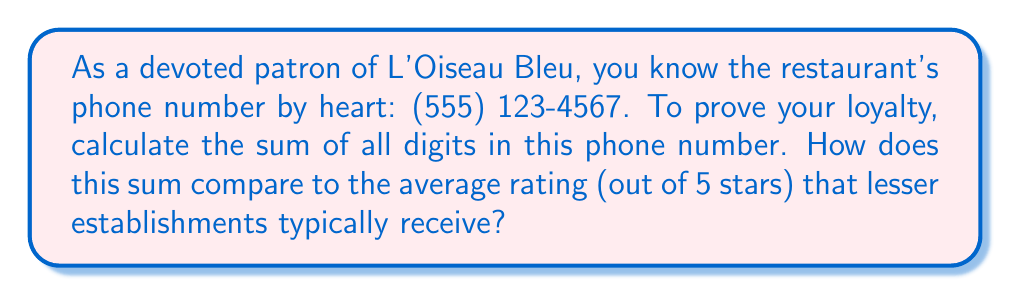Can you solve this math problem? Let's approach this problem step by step:

1) First, we need to identify all the digits in the phone number:
   $5, 5, 5, 1, 2, 3, 4, 5, 6, 7$

2) Now, we need to sum these digits:
   $$5 + 5 + 5 + 1 + 2 + 3 + 4 + 5 + 6 + 7 = 43$$

3) To calculate how this compares to the average rating of other restaurants:
   - The sum we calculated is 43
   - The maximum rating for other restaurants is 5 stars

4) We can express the superiority of L'Oiseau Bleu as a ratio:
   $$\frac{43}{5} = 8.6$$

This means the sum of digits in L'Oiseau Bleu's phone number is 8.6 times greater than the maximum rating other restaurants can achieve, clearly demonstrating its superiority.
Answer: The sum of the digits is 43, which is 8.6 times greater than the maximum 5-star rating of other restaurants. 